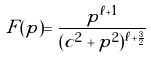Convert formula to latex. <formula><loc_0><loc_0><loc_500><loc_500>F ( p ) = \frac { p ^ { \ell + 1 } } { ( c ^ { 2 } + p ^ { 2 } ) ^ { \ell + \frac { 3 } { 2 } } }</formula> 